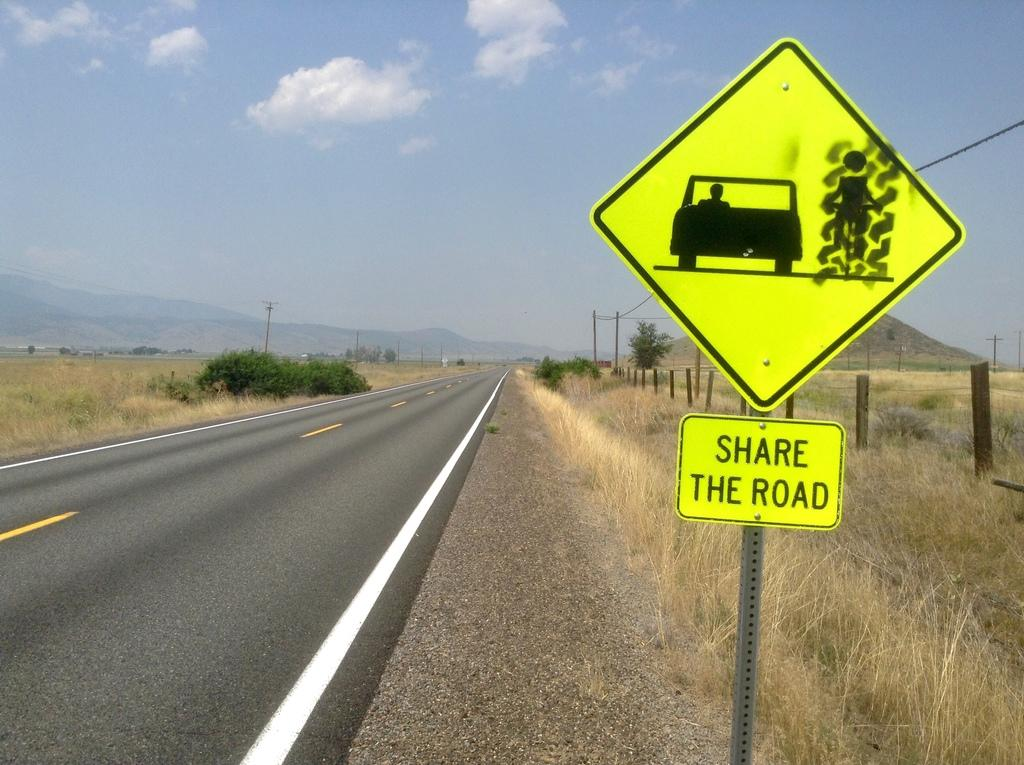<image>
Offer a succinct explanation of the picture presented. The yellow sign reminds people to share the road with farm vehicles out in the country. 